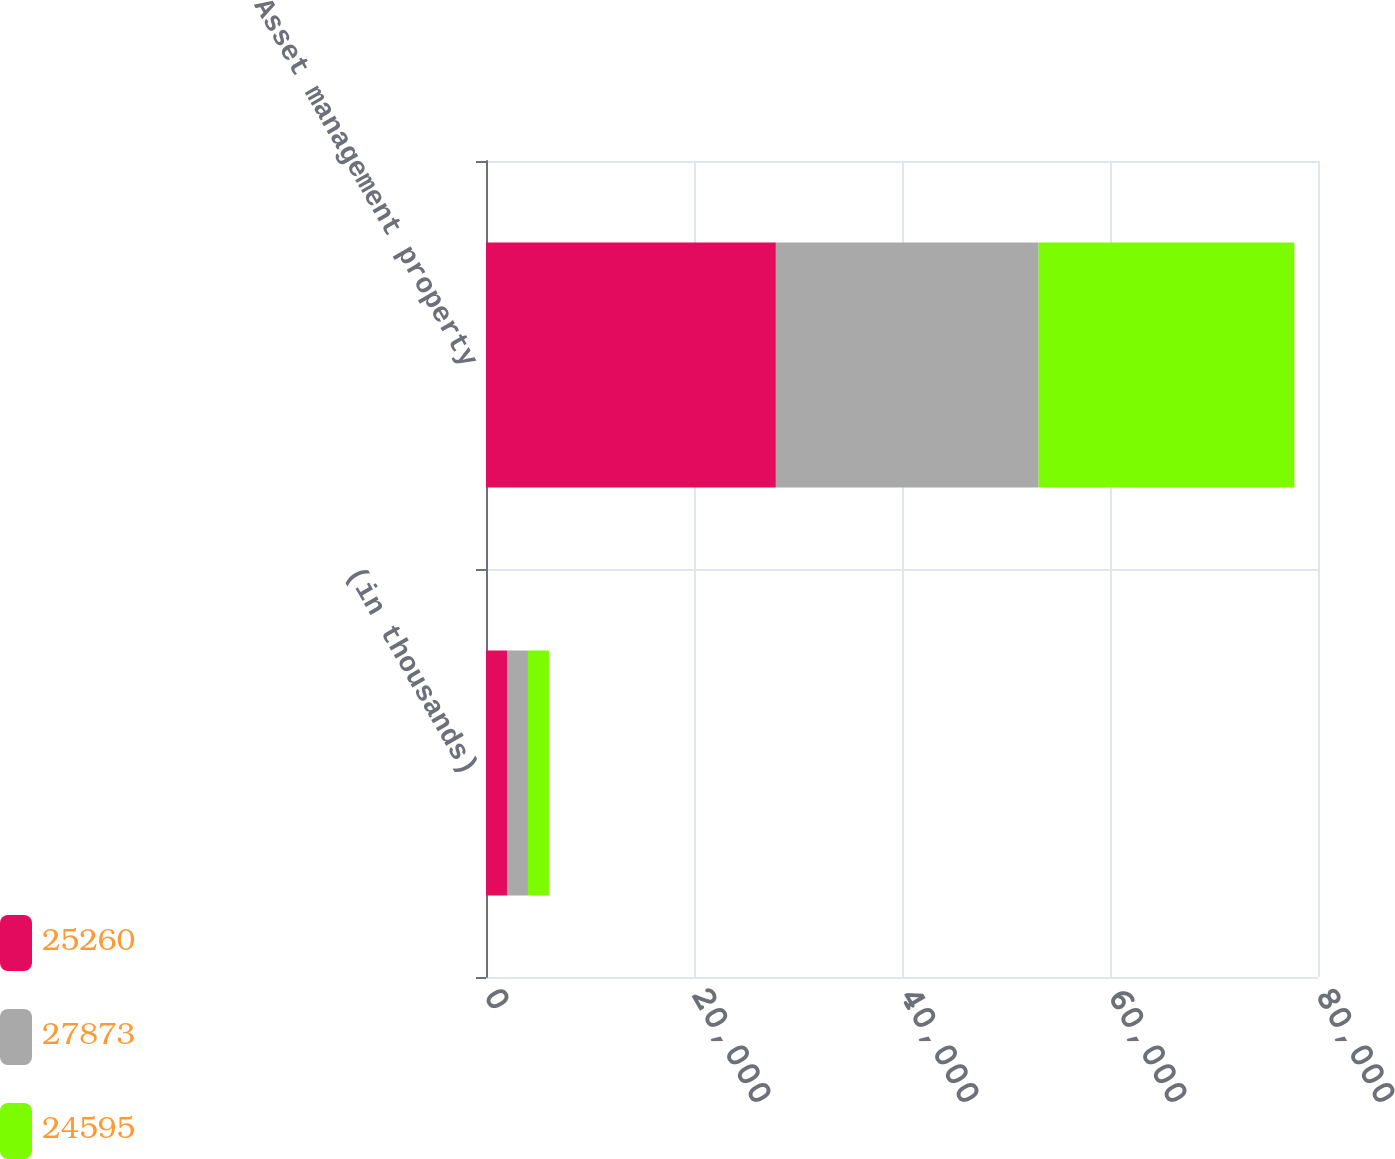Convert chart to OTSL. <chart><loc_0><loc_0><loc_500><loc_500><stacked_bar_chart><ecel><fcel>(in thousands)<fcel>Asset management property<nl><fcel>25260<fcel>2018<fcel>27873<nl><fcel>27873<fcel>2017<fcel>25260<nl><fcel>24595<fcel>2016<fcel>24595<nl></chart> 